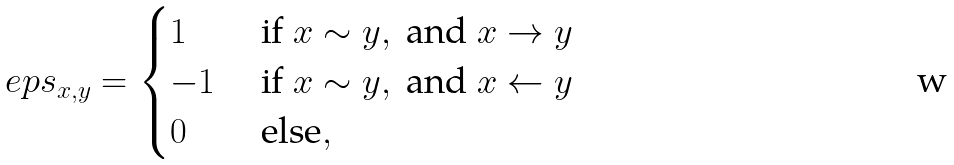<formula> <loc_0><loc_0><loc_500><loc_500>\ e p s _ { x , y } = \begin{cases} 1 & \text { if } x \sim y , \text { and } x \rightarrow y \\ - 1 & \text { if } x \sim y , \text { and } x \leftarrow y \\ 0 & \text { else} , \end{cases}</formula> 